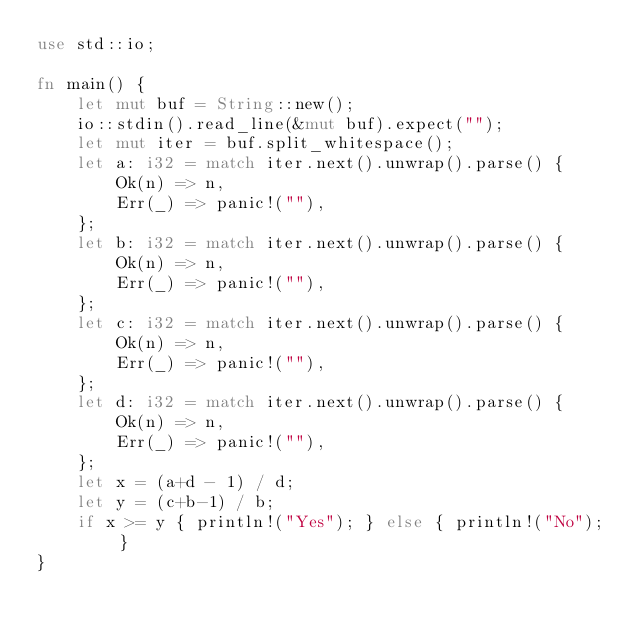<code> <loc_0><loc_0><loc_500><loc_500><_Rust_>use std::io;

fn main() {
	let mut buf = String::new();
	io::stdin().read_line(&mut buf).expect("");
	let mut iter = buf.split_whitespace();
	let a: i32 = match iter.next().unwrap().parse() {
		Ok(n) => n,
		Err(_) => panic!(""),
	};
	let b: i32 = match iter.next().unwrap().parse() {
		Ok(n) => n,
		Err(_) => panic!(""),
	};
	let c: i32 = match iter.next().unwrap().parse() {
		Ok(n) => n,
		Err(_) => panic!(""),
	};
	let d: i32 = match iter.next().unwrap().parse() {
		Ok(n) => n,
		Err(_) => panic!(""),
	};
	let x = (a+d - 1) / d;
	let y = (c+b-1) / b;
	if x >= y { println!("Yes"); } else { println!("No"); }
}</code> 